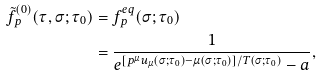Convert formula to latex. <formula><loc_0><loc_0><loc_500><loc_500>\tilde { f } _ { p } ^ { ( 0 ) } ( \tau , \sigma ; \tau _ { 0 } ) & = f ^ { e q } _ { p } ( \sigma ; \tau _ { 0 } ) \\ & = \frac { 1 } { e ^ { [ p ^ { \mu } u _ { \mu } ( \sigma ; \tau _ { 0 } ) - \mu ( \sigma ; \tau _ { 0 } ) ] / T ( \sigma ; \tau _ { 0 } ) } - a } ,</formula> 